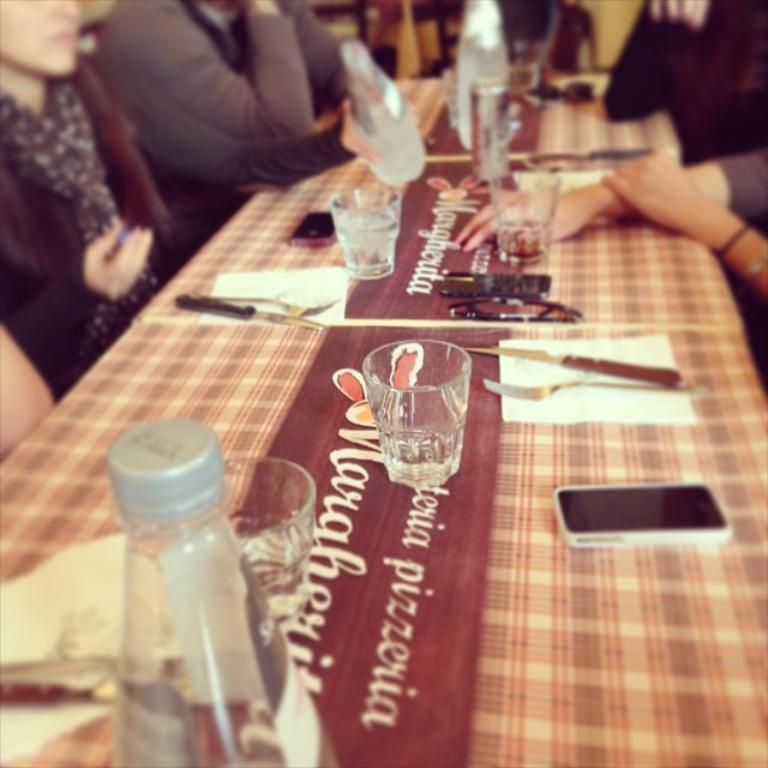What is happening around the table in the image? There are people around the table in the image. What items can be seen on the table? There are glasses, bottles, tissue papers, knives, and a mobile phone on the table. Are there any other objects on the table? Yes, there are other objects on the table. What type of beetle can be seen crawling on the mobile phone in the image? There is no beetle present in the image; the mobile phone is the only item mentioned on the table. What achievement has the man in the image accomplished? There is no man mentioned in the image, and no achievements are discussed. 